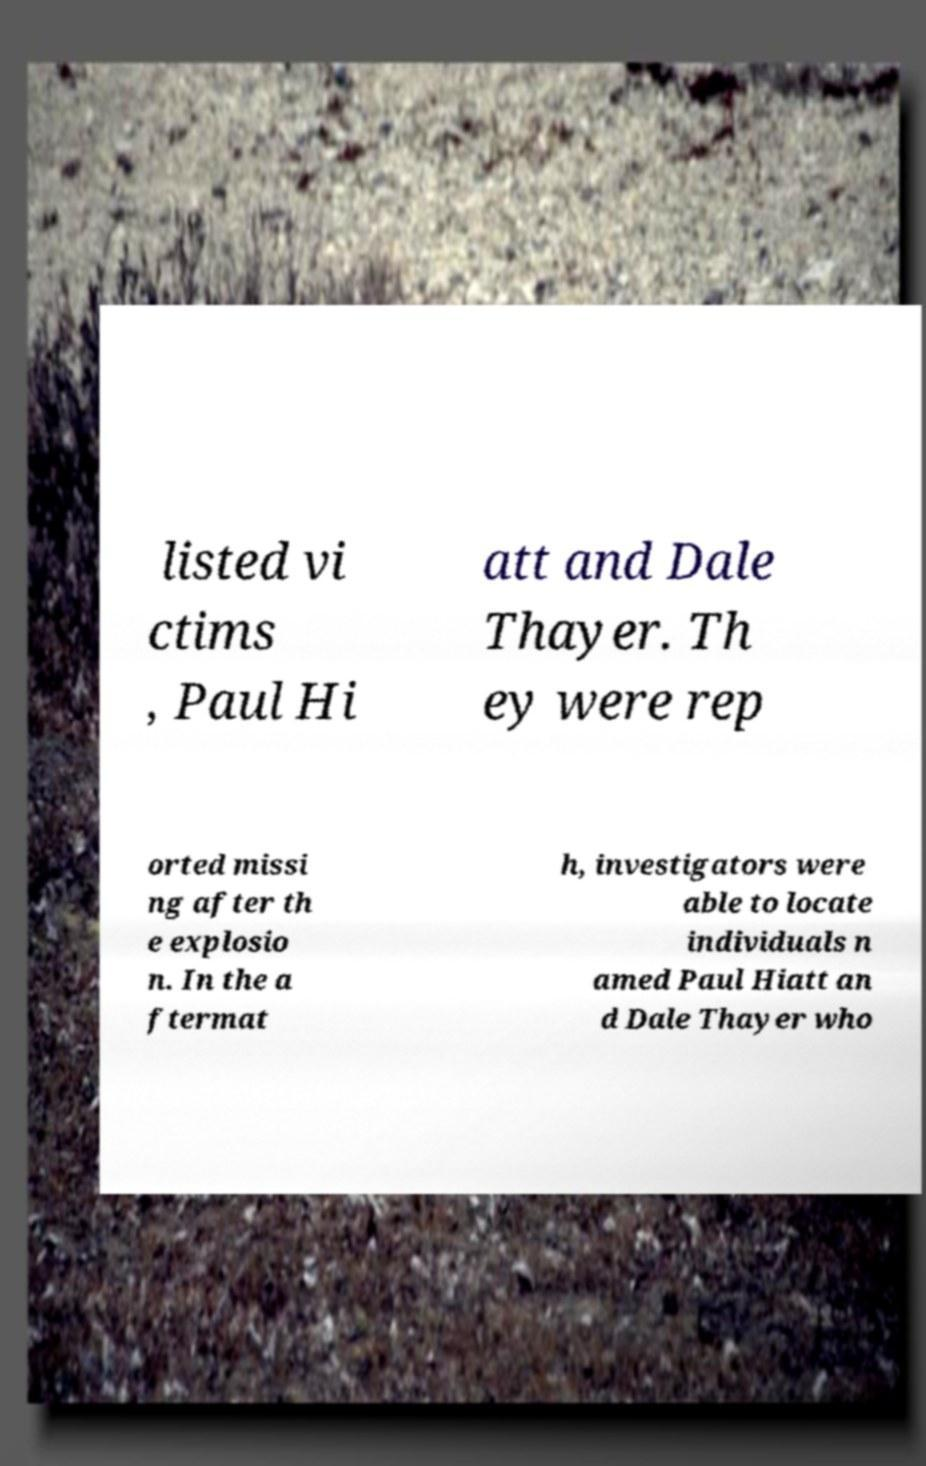Could you assist in decoding the text presented in this image and type it out clearly? listed vi ctims , Paul Hi att and Dale Thayer. Th ey were rep orted missi ng after th e explosio n. In the a ftermat h, investigators were able to locate individuals n amed Paul Hiatt an d Dale Thayer who 